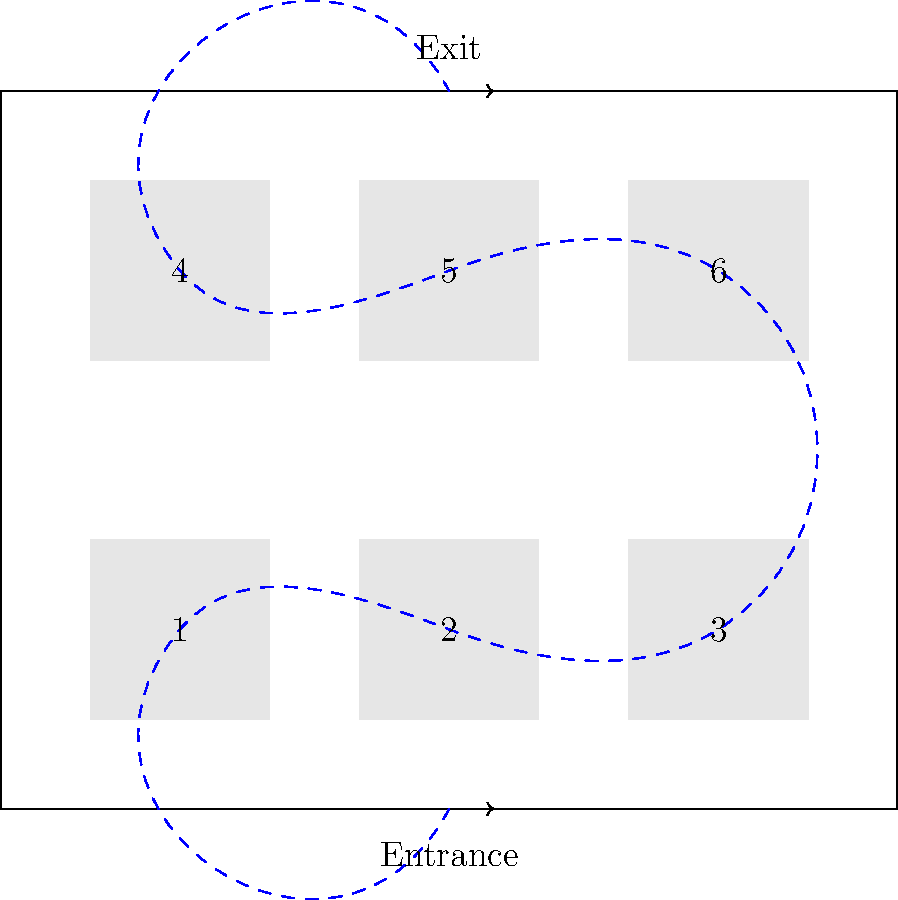Based on the provided museum floor plan, which exhibit layout and visitor flow pattern would likely maximize engagement and minimize congestion? Justify your answer considering the principles of museum design and visitor behavior. To answer this question, we need to consider several factors related to museum design and visitor behavior:

1. Entrance and Exit placement:
   The entrance and exit are centrally located on opposite sides of the museum, which is ideal for controlling visitor flow.

2. Exhibit layout:
   The exhibits are arranged in two rows of three, creating a balanced layout that allows for easy navigation.

3. Suggested path:
   The dashed blue line indicates a suggested visitor path that follows a logical sequence through the exhibits.

4. Visitor behavior principles:
   - Most visitors tend to turn right upon entering a space.
   - People typically move counterclockwise through exhibits.
   - Visitors often experience "museum fatigue" towards the end of their visit.

5. Engagement and congestion considerations:
   - The suggested path encourages visitors to see all exhibits.
   - The layout allows for multiple paths, reducing bottlenecks.
   - The central area provides space for visitors to move between exhibits.

6. Optimization:
   The current layout and suggested path appear to be well-optimized because:
   - It follows the natural right-turn tendency at the entrance.
   - It guides visitors in a counterclockwise direction.
   - It places potentially less popular exhibits (4, 5, 6) towards the end of the visit when fatigue may set in.
   - It allows for flexibility in movement, preventing congestion.

7. Potential improvements:
   - Adding rest areas or interactive spaces between exhibits could further enhance engagement and reduce fatigue.
   - Ensuring exhibit 1 is particularly engaging could capitalize on the initial visitor enthusiasm.

Given these considerations, the current layout and suggested path are well-designed to maximize engagement and minimize congestion. However, minor adjustments such as adding rest areas could further optimize the visitor experience.
Answer: The current layout and suggested path effectively maximize engagement and minimize congestion, following key principles of visitor behavior and museum design. Minor improvements like adding rest areas could further optimize the experience. 